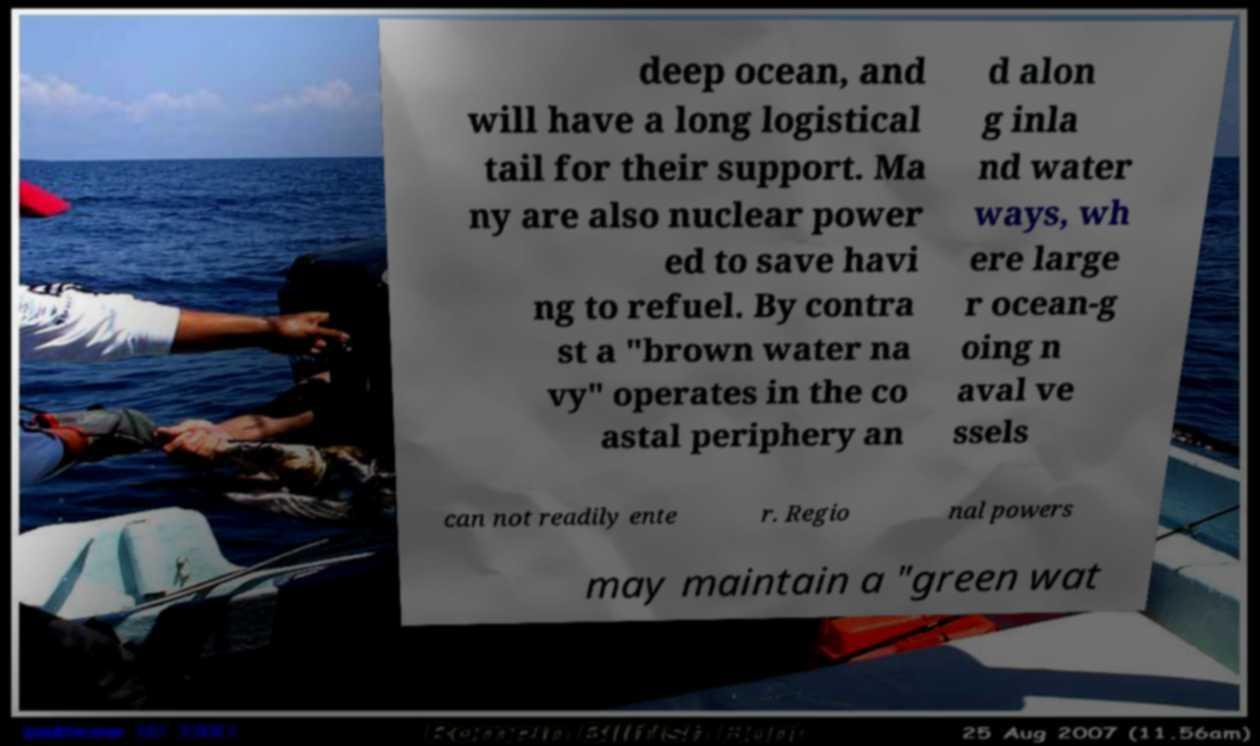Can you read and provide the text displayed in the image?This photo seems to have some interesting text. Can you extract and type it out for me? deep ocean, and will have a long logistical tail for their support. Ma ny are also nuclear power ed to save havi ng to refuel. By contra st a "brown water na vy" operates in the co astal periphery an d alon g inla nd water ways, wh ere large r ocean-g oing n aval ve ssels can not readily ente r. Regio nal powers may maintain a "green wat 